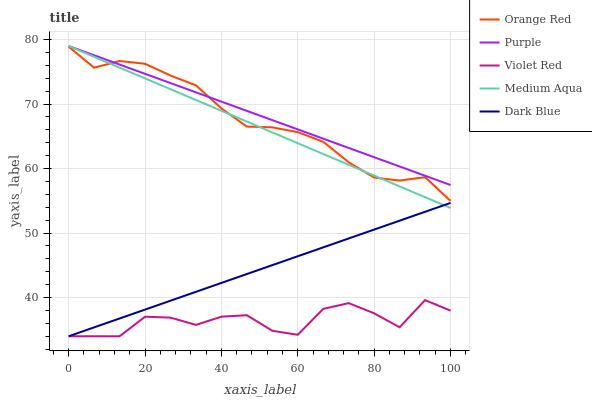Does Dark Blue have the minimum area under the curve?
Answer yes or no. No. Does Dark Blue have the maximum area under the curve?
Answer yes or no. No. Is Violet Red the smoothest?
Answer yes or no. No. Is Dark Blue the roughest?
Answer yes or no. No. Does Medium Aqua have the lowest value?
Answer yes or no. No. Does Dark Blue have the highest value?
Answer yes or no. No. Is Dark Blue less than Purple?
Answer yes or no. Yes. Is Orange Red greater than Violet Red?
Answer yes or no. Yes. Does Dark Blue intersect Purple?
Answer yes or no. No. 